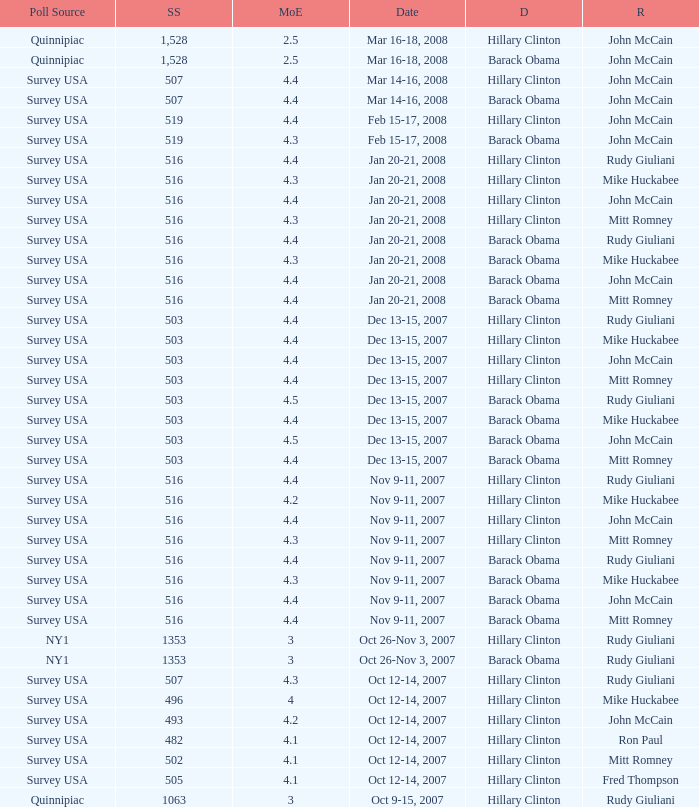What is the sample size of the poll taken on Dec 13-15, 2007 that had a margin of error of more than 4 and resulted with Republican Mike Huckabee? 503.0. 